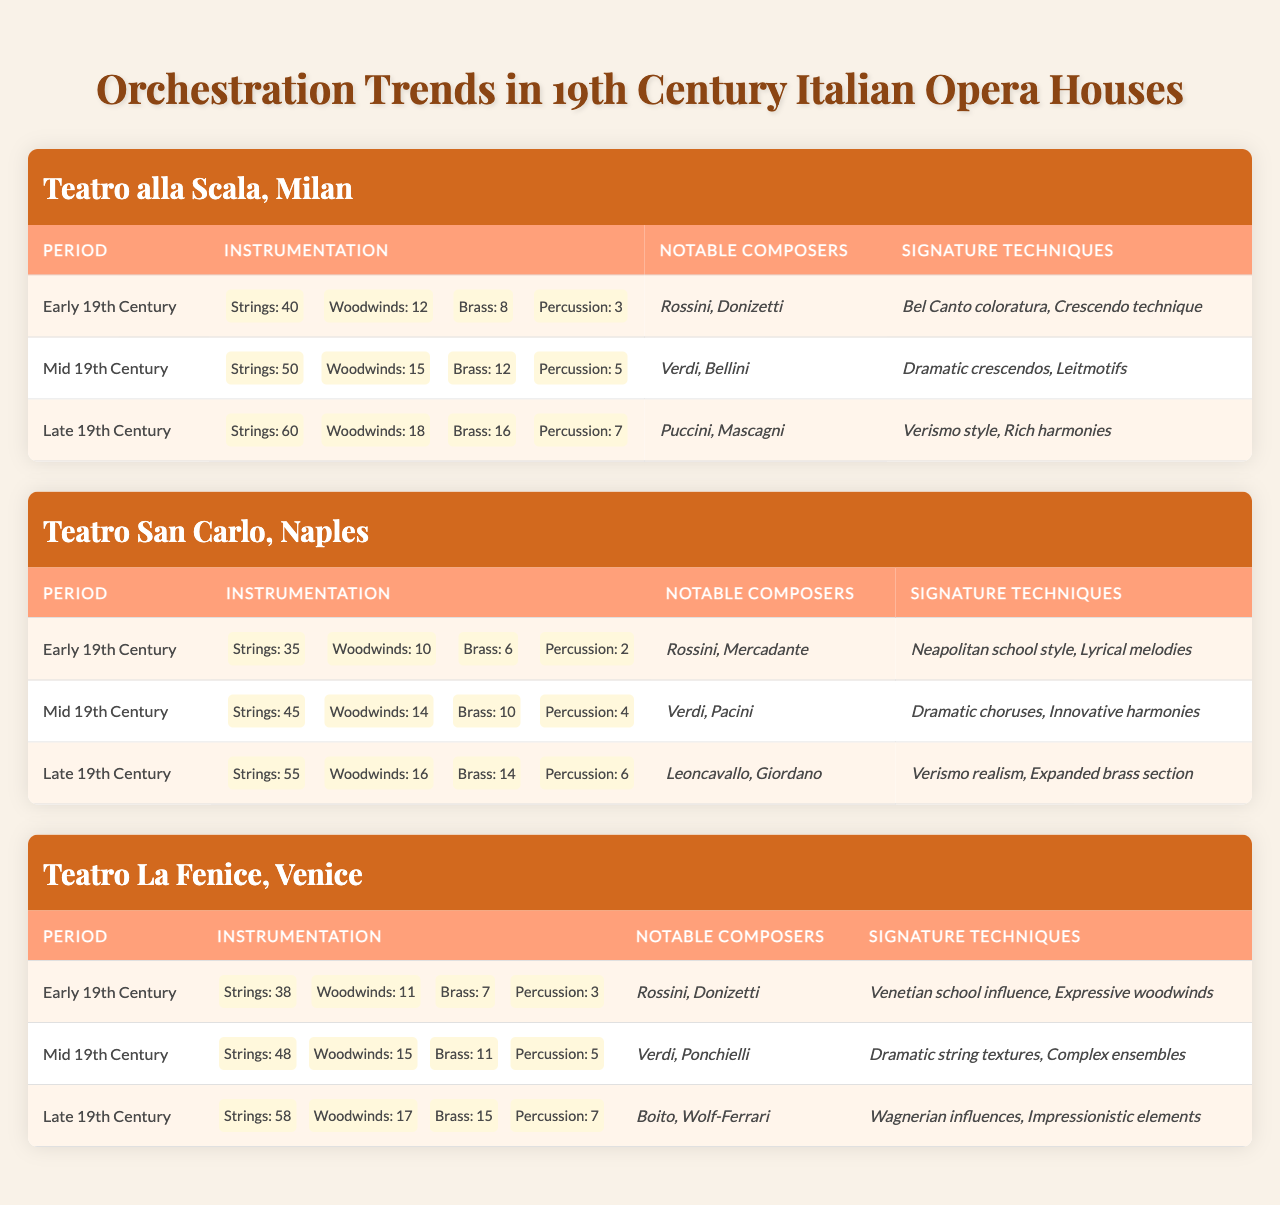What was the maximum number of strings used in the orchestration during the Late 19th Century at any of the opera houses? In the Late 19th Century, Teatro alla Scala used 60 strings, Teatro San Carlo used 55 strings, and Teatro La Fenice used 58 strings. The maximum number is 60.
Answer: 60 Which notable composer was associated with the Early 19th Century trends at Teatro San Carlo? According to the table, Rossini and Mercadante were the notable composers for the Early 19th Century at Teatro San Carlo. Thus, one of them is Rossini.
Answer: Rossini How many brass instruments were used in the orchestration at Teatro alla Scala during the Mid 19th Century? The table states that the orchestration at Teatro alla Scala in the Mid 19th Century included 12 brass instruments.
Answer: 12 Which opera house had the highest total instrumentation count in the Mid 19th Century, and what was that total? Calculating the total instrumentation for each opera house in the Mid 19th Century: Teatro alla Scala (50+15+12+5=82), Teatro San Carlo (45+14+10+4=73), Teatro La Fenice (48+15+11+5=79). The highest count is 82 for Teatro alla Scala.
Answer: Teatro alla Scala, 82 Did Teatro La Fenice have more woodwinds in the Late 19th Century compared to Teatro San Carlo? In the Late 19th Century, Teatro La Fenice had 17 woodwinds, while Teatro San Carlo had 16 woodwinds. Therefore, Teatro La Fenice had more.
Answer: Yes What was the average number of percussion instruments across all three opera houses during the Early 19th Century? Summing the percussion instruments: Teatro alla Scala had 3, Teatro San Carlo had 2, and Teatro La Fenice had 3, yielding a total of 8. Since there are 3 opera houses, the average is 8/3, which is approximately 2.67.
Answer: Approximately 2.67 Which signature technique was unique to the Late 19th Century trends at Teatro San Carlo? The table indicates that "Expanded brass section" was a signature technique for Teatro San Carlo in the Late 19th Century, whereas it is not listed for other opera houses.
Answer: Expanded brass section How did the number of strings used in the Early 19th Century compare to those used in the Late 19th Century for Teatro alla Scala? In the Early 19th Century, Teatro alla Scala used 40 strings, and in the Late 19th Century, they used 60 strings. The difference is calculated as 60 - 40 = 20, indicating an increase.
Answer: Increased by 20 What percentage of the total orchestration at Teatro San Carlo in the Mid 19th Century was made up of woodwinds? At Teatro San Carlo in the Mid 19th Century, the total orchestration is 45 (strings) + 14 (woodwinds) + 10 (brass) + 4 (percussion) = 73. The woodwinds are 14, making the percentage (14/73) * 100, approximately 19.18%.
Answer: Approximately 19.18% What were the two notable composers associated with the Late 19th Century at Teatro La Fenice? The table lists Boito and Wolf-Ferrari as the notable composers for the Late 19th Century at Teatro La Fenice.
Answer: Boito, Wolf-Ferrari 